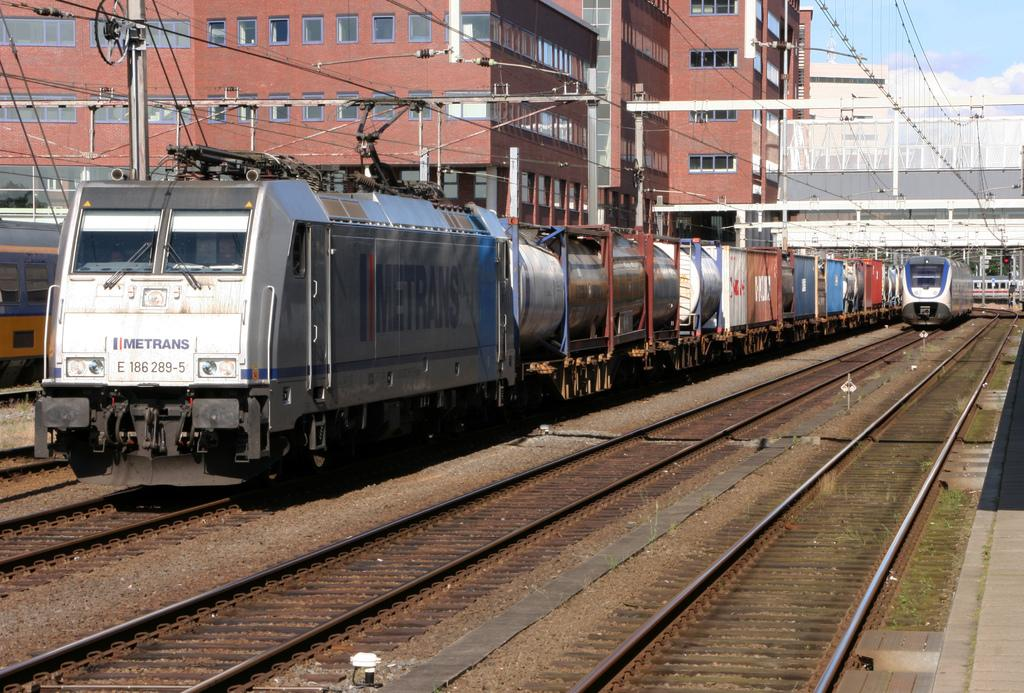<image>
Summarize the visual content of the image. The back of an industrial train, next to a large building, has the brand Imetrans painted in red and blue letters. 